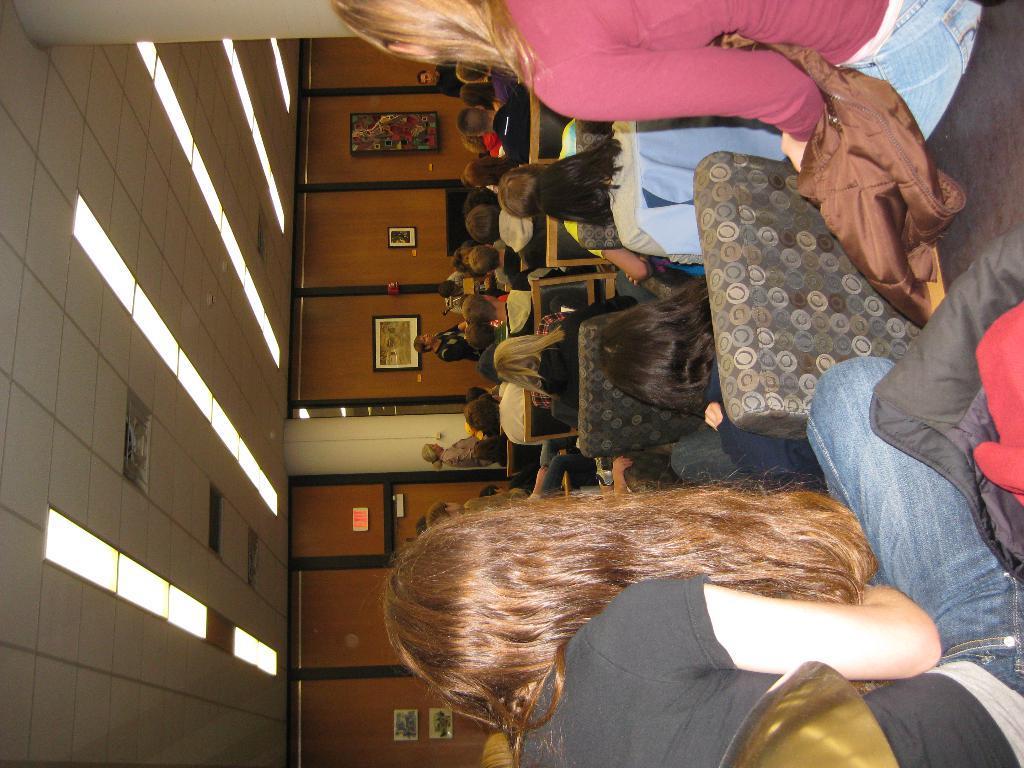Could you give a brief overview of what you see in this image? This is a rotated image. In this image there are a few people sitting on the chairs, in front of them there are a few people standing. In the background of the image there are a few frames hanging on the wall. At the top of the image there is a ceiling with lights. 